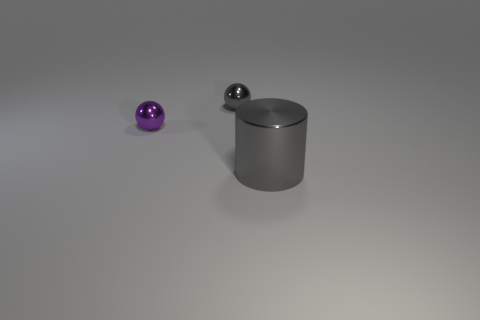Add 2 large gray shiny cylinders. How many objects exist? 5 Subtract all spheres. How many objects are left? 1 Subtract 0 blue cylinders. How many objects are left? 3 Subtract all big cyan rubber objects. Subtract all tiny gray things. How many objects are left? 2 Add 3 gray metallic spheres. How many gray metallic spheres are left? 4 Add 2 tiny things. How many tiny things exist? 4 